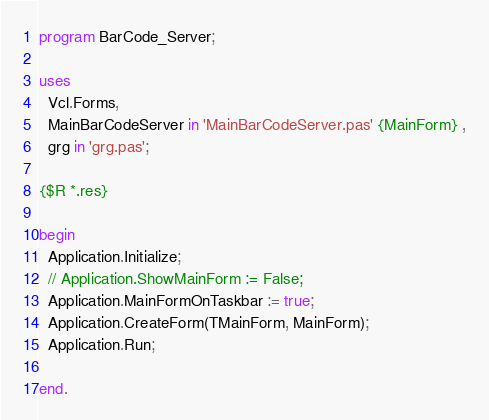<code> <loc_0><loc_0><loc_500><loc_500><_Pascal_>program BarCode_Server;

uses
  Vcl.Forms,
  MainBarCodeServer in 'MainBarCodeServer.pas' {MainForm} ,
  grg in 'grg.pas';

{$R *.res}

begin
  Application.Initialize;
  // Application.ShowMainForm := False;
  Application.MainFormOnTaskbar := true;
  Application.CreateForm(TMainForm, MainForm);
  Application.Run;

end.
</code> 